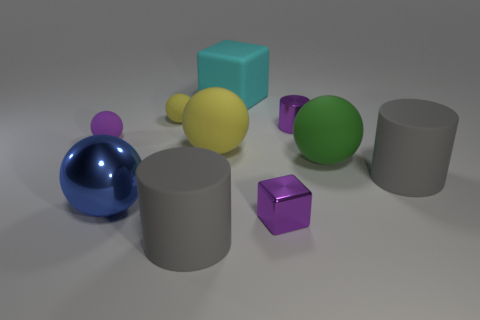Subtract all purple spheres. How many spheres are left? 4 Subtract all large green rubber balls. How many balls are left? 4 Subtract 2 balls. How many balls are left? 3 Subtract all green balls. Subtract all green cubes. How many balls are left? 4 Subtract 1 green spheres. How many objects are left? 9 Subtract all cylinders. How many objects are left? 7 Subtract all large cyan matte blocks. Subtract all large matte spheres. How many objects are left? 7 Add 1 matte spheres. How many matte spheres are left? 5 Add 7 purple metallic things. How many purple metallic things exist? 9 